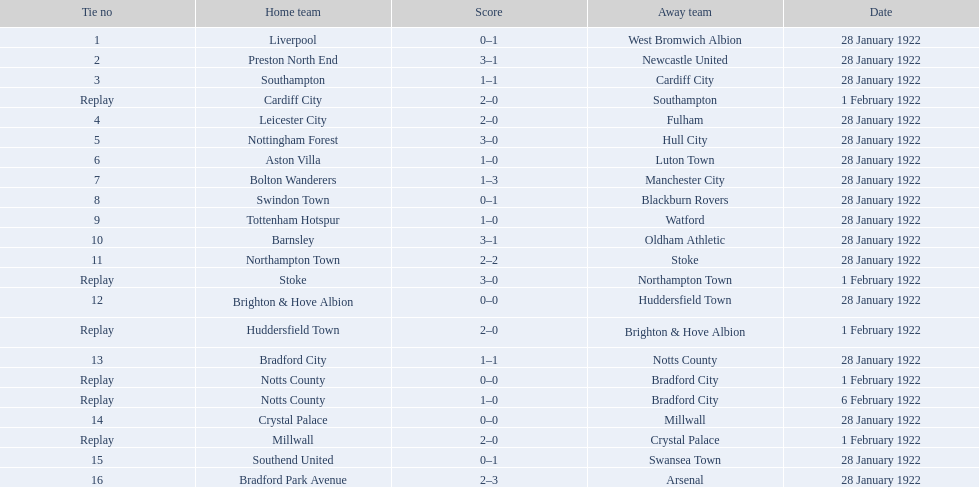What was the score in the aston villa game? 1–0. Which other team had an identical score? Tottenham Hotspur. What was the outcome of the game involving aston villa? 1–0. Which other team achieved the same scoreline? Tottenham Hotspur. 